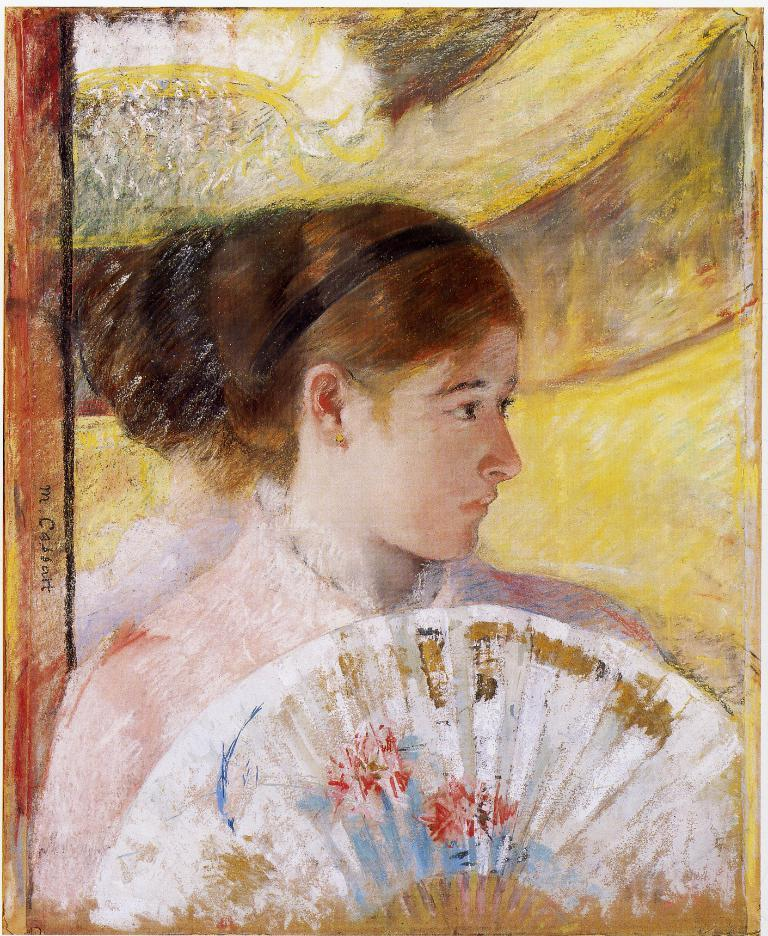What is the main subject of the image? There is a painting in the image. What is depicted in the painting? The painting features a woman. What object is the woman holding in the painting? The woman is holding a Chinese fan. What type of glove is the woman wearing in the painting? There is no glove present in the painting; the woman is holding a Chinese fan. 